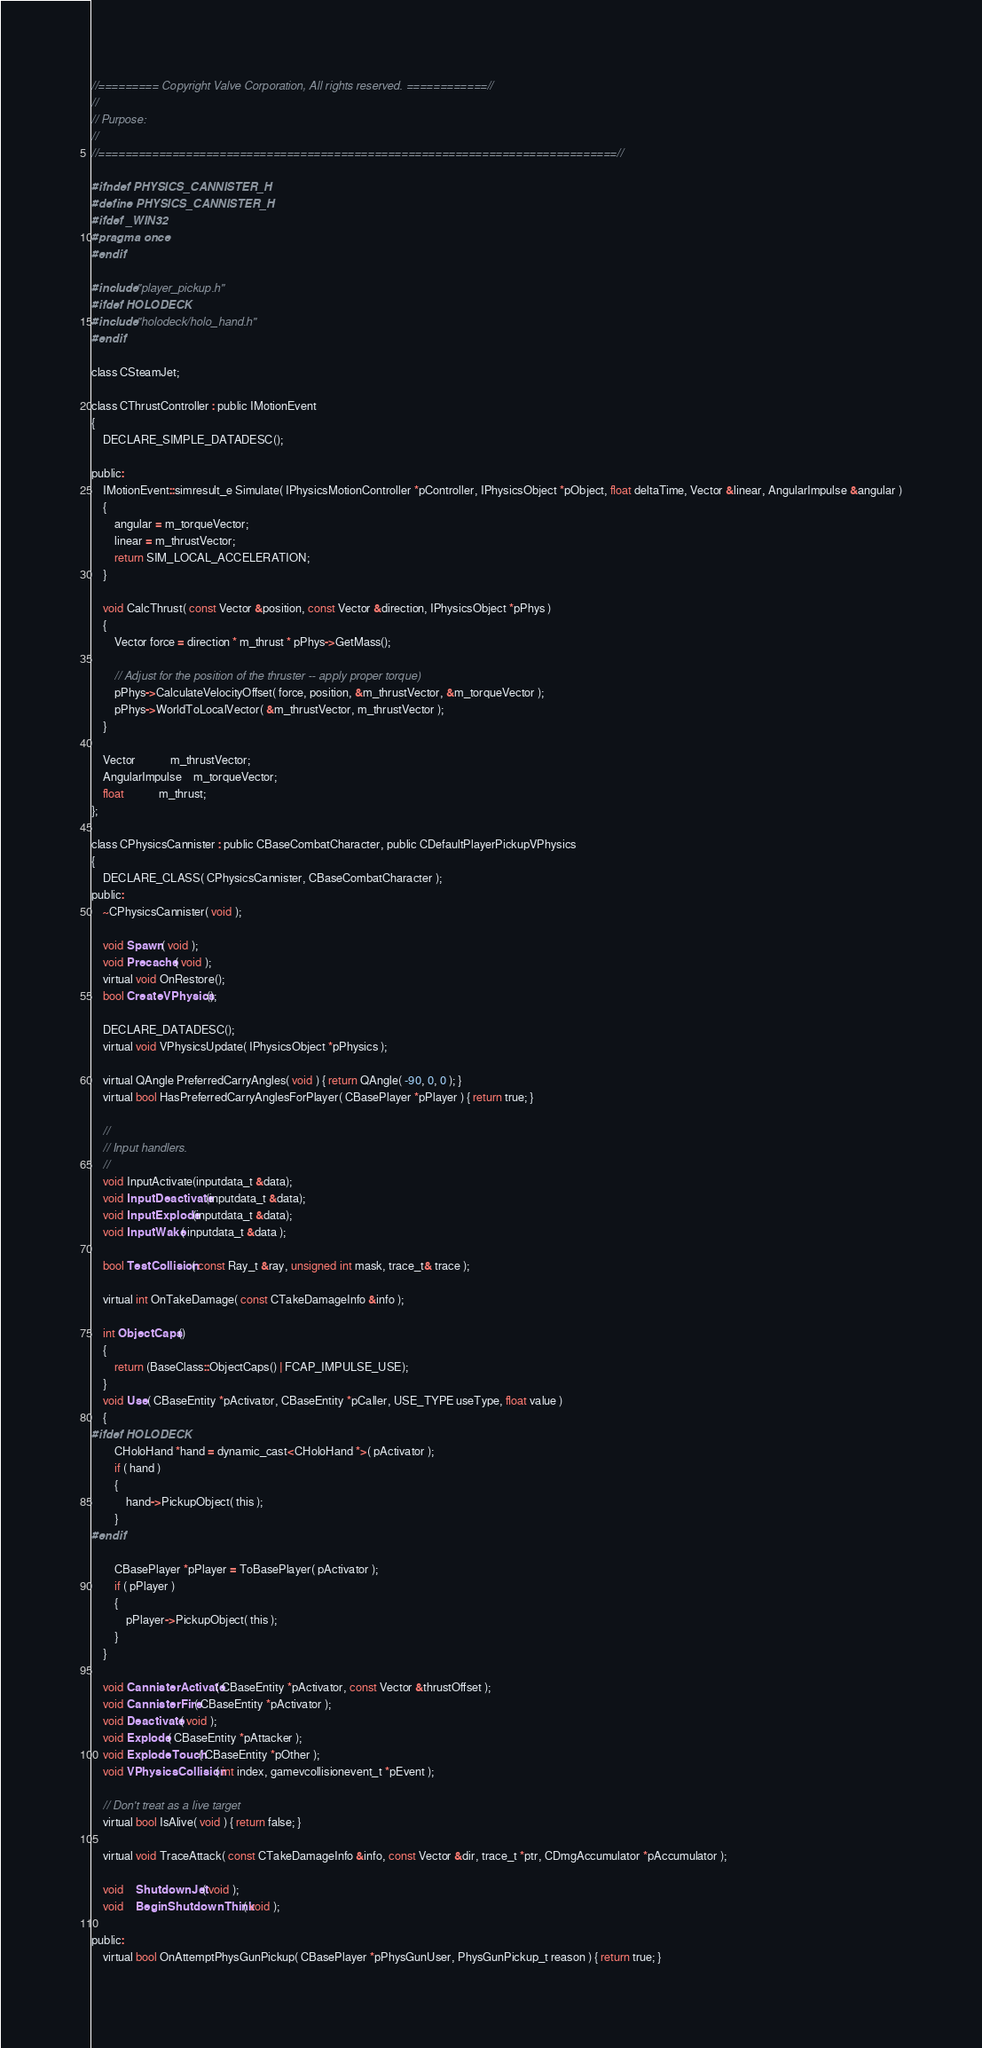<code> <loc_0><loc_0><loc_500><loc_500><_C_>//========= Copyright Valve Corporation, All rights reserved. ============//
//
// Purpose: 
//
//=============================================================================//

#ifndef PHYSICS_CANNISTER_H
#define PHYSICS_CANNISTER_H
#ifdef _WIN32
#pragma once
#endif

#include "player_pickup.h"
#ifdef HOLODECK
#include "holodeck/holo_hand.h"
#endif

class CSteamJet;

class CThrustController : public IMotionEvent
{
	DECLARE_SIMPLE_DATADESC();

public:
	IMotionEvent::simresult_e Simulate( IPhysicsMotionController *pController, IPhysicsObject *pObject, float deltaTime, Vector &linear, AngularImpulse &angular )
	{
		angular = m_torqueVector;
		linear = m_thrustVector;
		return SIM_LOCAL_ACCELERATION;
	}

	void CalcThrust( const Vector &position, const Vector &direction, IPhysicsObject *pPhys )
	{
		Vector force = direction * m_thrust * pPhys->GetMass();
		
		// Adjust for the position of the thruster -- apply proper torque)
		pPhys->CalculateVelocityOffset( force, position, &m_thrustVector, &m_torqueVector );
		pPhys->WorldToLocalVector( &m_thrustVector, m_thrustVector );
	}

	Vector			m_thrustVector;
	AngularImpulse	m_torqueVector;
	float			m_thrust;
};

class CPhysicsCannister : public CBaseCombatCharacter, public CDefaultPlayerPickupVPhysics
{
	DECLARE_CLASS( CPhysicsCannister, CBaseCombatCharacter );
public:
	~CPhysicsCannister( void );

	void Spawn( void );
	void Precache( void );
	virtual void OnRestore();
	bool CreateVPhysics();

	DECLARE_DATADESC();
	virtual void VPhysicsUpdate( IPhysicsObject *pPhysics );

	virtual QAngle PreferredCarryAngles( void ) { return QAngle( -90, 0, 0 ); }
	virtual bool HasPreferredCarryAnglesForPlayer( CBasePlayer *pPlayer ) { return true; }

	//
	// Input handlers.
	//
	void InputActivate(inputdata_t &data);
	void InputDeactivate(inputdata_t &data);
	void InputExplode(inputdata_t &data);
	void InputWake( inputdata_t &data );

	bool TestCollision( const Ray_t &ray, unsigned int mask, trace_t& trace );

	virtual int OnTakeDamage( const CTakeDamageInfo &info );

	int ObjectCaps() 
	{ 
		return (BaseClass::ObjectCaps() | FCAP_IMPULSE_USE);
	}
	void Use( CBaseEntity *pActivator, CBaseEntity *pCaller, USE_TYPE useType, float value )
	{
#ifdef HOLODECK
		CHoloHand *hand = dynamic_cast<CHoloHand *>( pActivator );
		if ( hand )
		{
			hand->PickupObject( this );
		}
#endif

		CBasePlayer *pPlayer = ToBasePlayer( pActivator );
		if ( pPlayer )
		{
			pPlayer->PickupObject( this );
		}
	}

	void CannisterActivate( CBaseEntity *pActivator, const Vector &thrustOffset );
	void CannisterFire( CBaseEntity *pActivator );
	void Deactivate( void );
	void Explode( CBaseEntity *pAttacker );
	void ExplodeTouch( CBaseEntity *pOther );
	void VPhysicsCollision( int index, gamevcollisionevent_t *pEvent );

	// Don't treat as a live target
	virtual bool IsAlive( void ) { return false; }

	virtual void TraceAttack( const CTakeDamageInfo &info, const Vector &dir, trace_t *ptr, CDmgAccumulator *pAccumulator );

	void	ShutdownJet( void );
	void	BeginShutdownThink( void );

public:
	virtual bool OnAttemptPhysGunPickup( CBasePlayer *pPhysGunUser, PhysGunPickup_t reason ) { return true; }</code> 